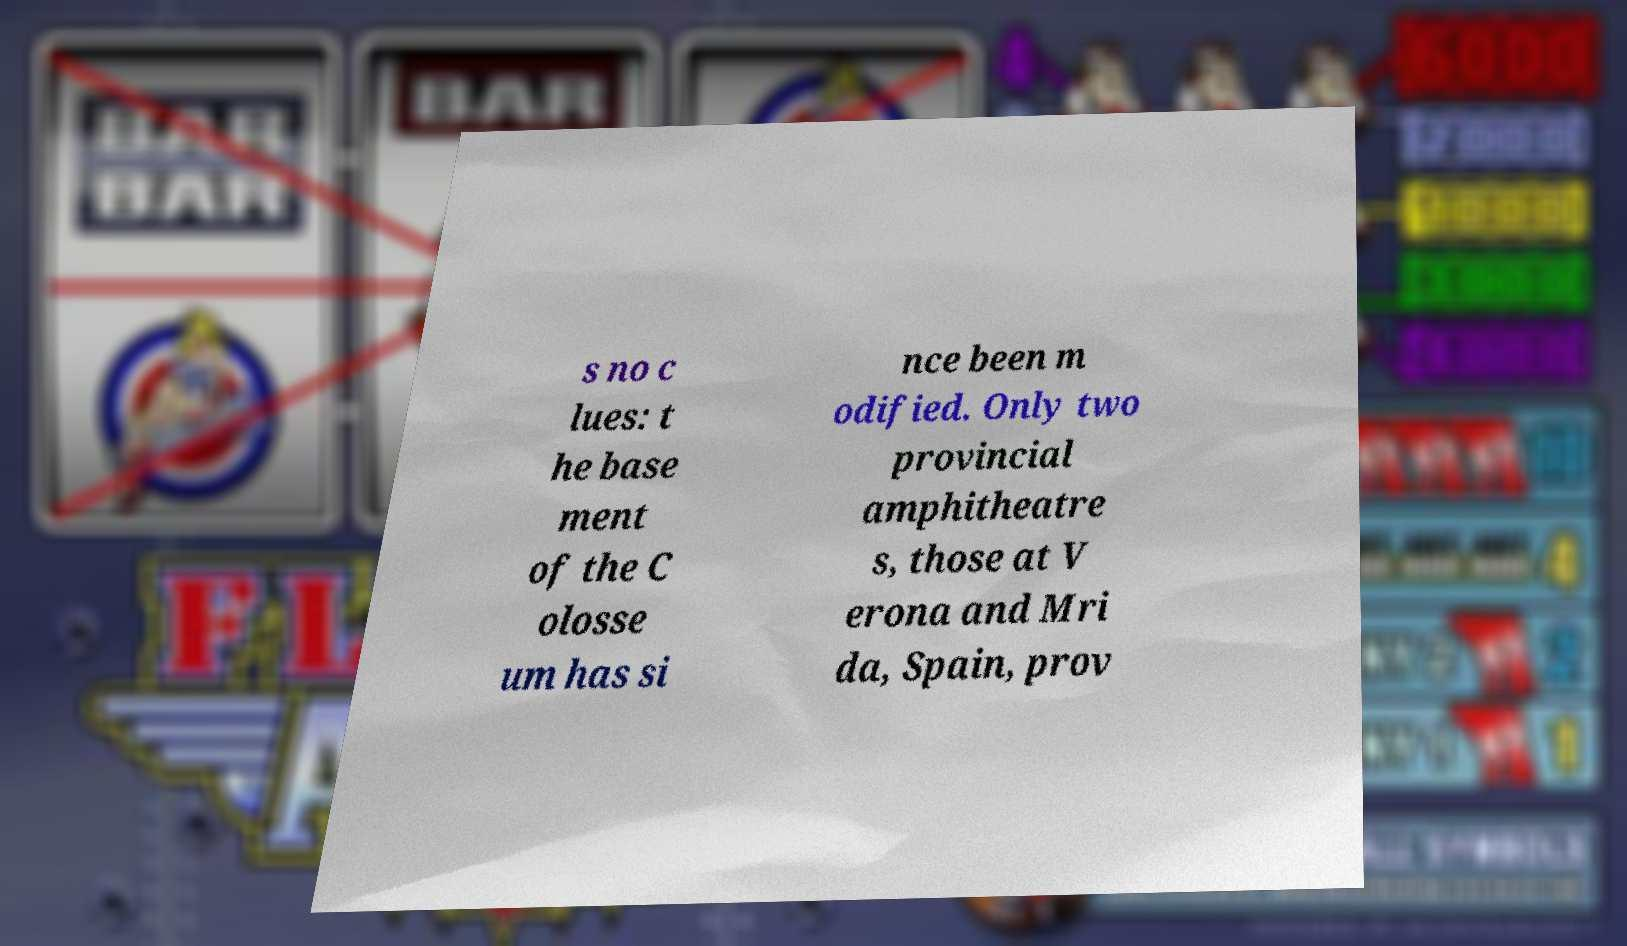For documentation purposes, I need the text within this image transcribed. Could you provide that? s no c lues: t he base ment of the C olosse um has si nce been m odified. Only two provincial amphitheatre s, those at V erona and Mri da, Spain, prov 